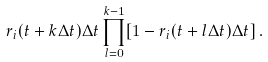Convert formula to latex. <formula><loc_0><loc_0><loc_500><loc_500>r _ { i } ( t + k \Delta t ) \Delta t \prod _ { l = 0 } ^ { k - 1 } [ 1 - r _ { i } ( t + l \Delta t ) \Delta t ] \, .</formula> 